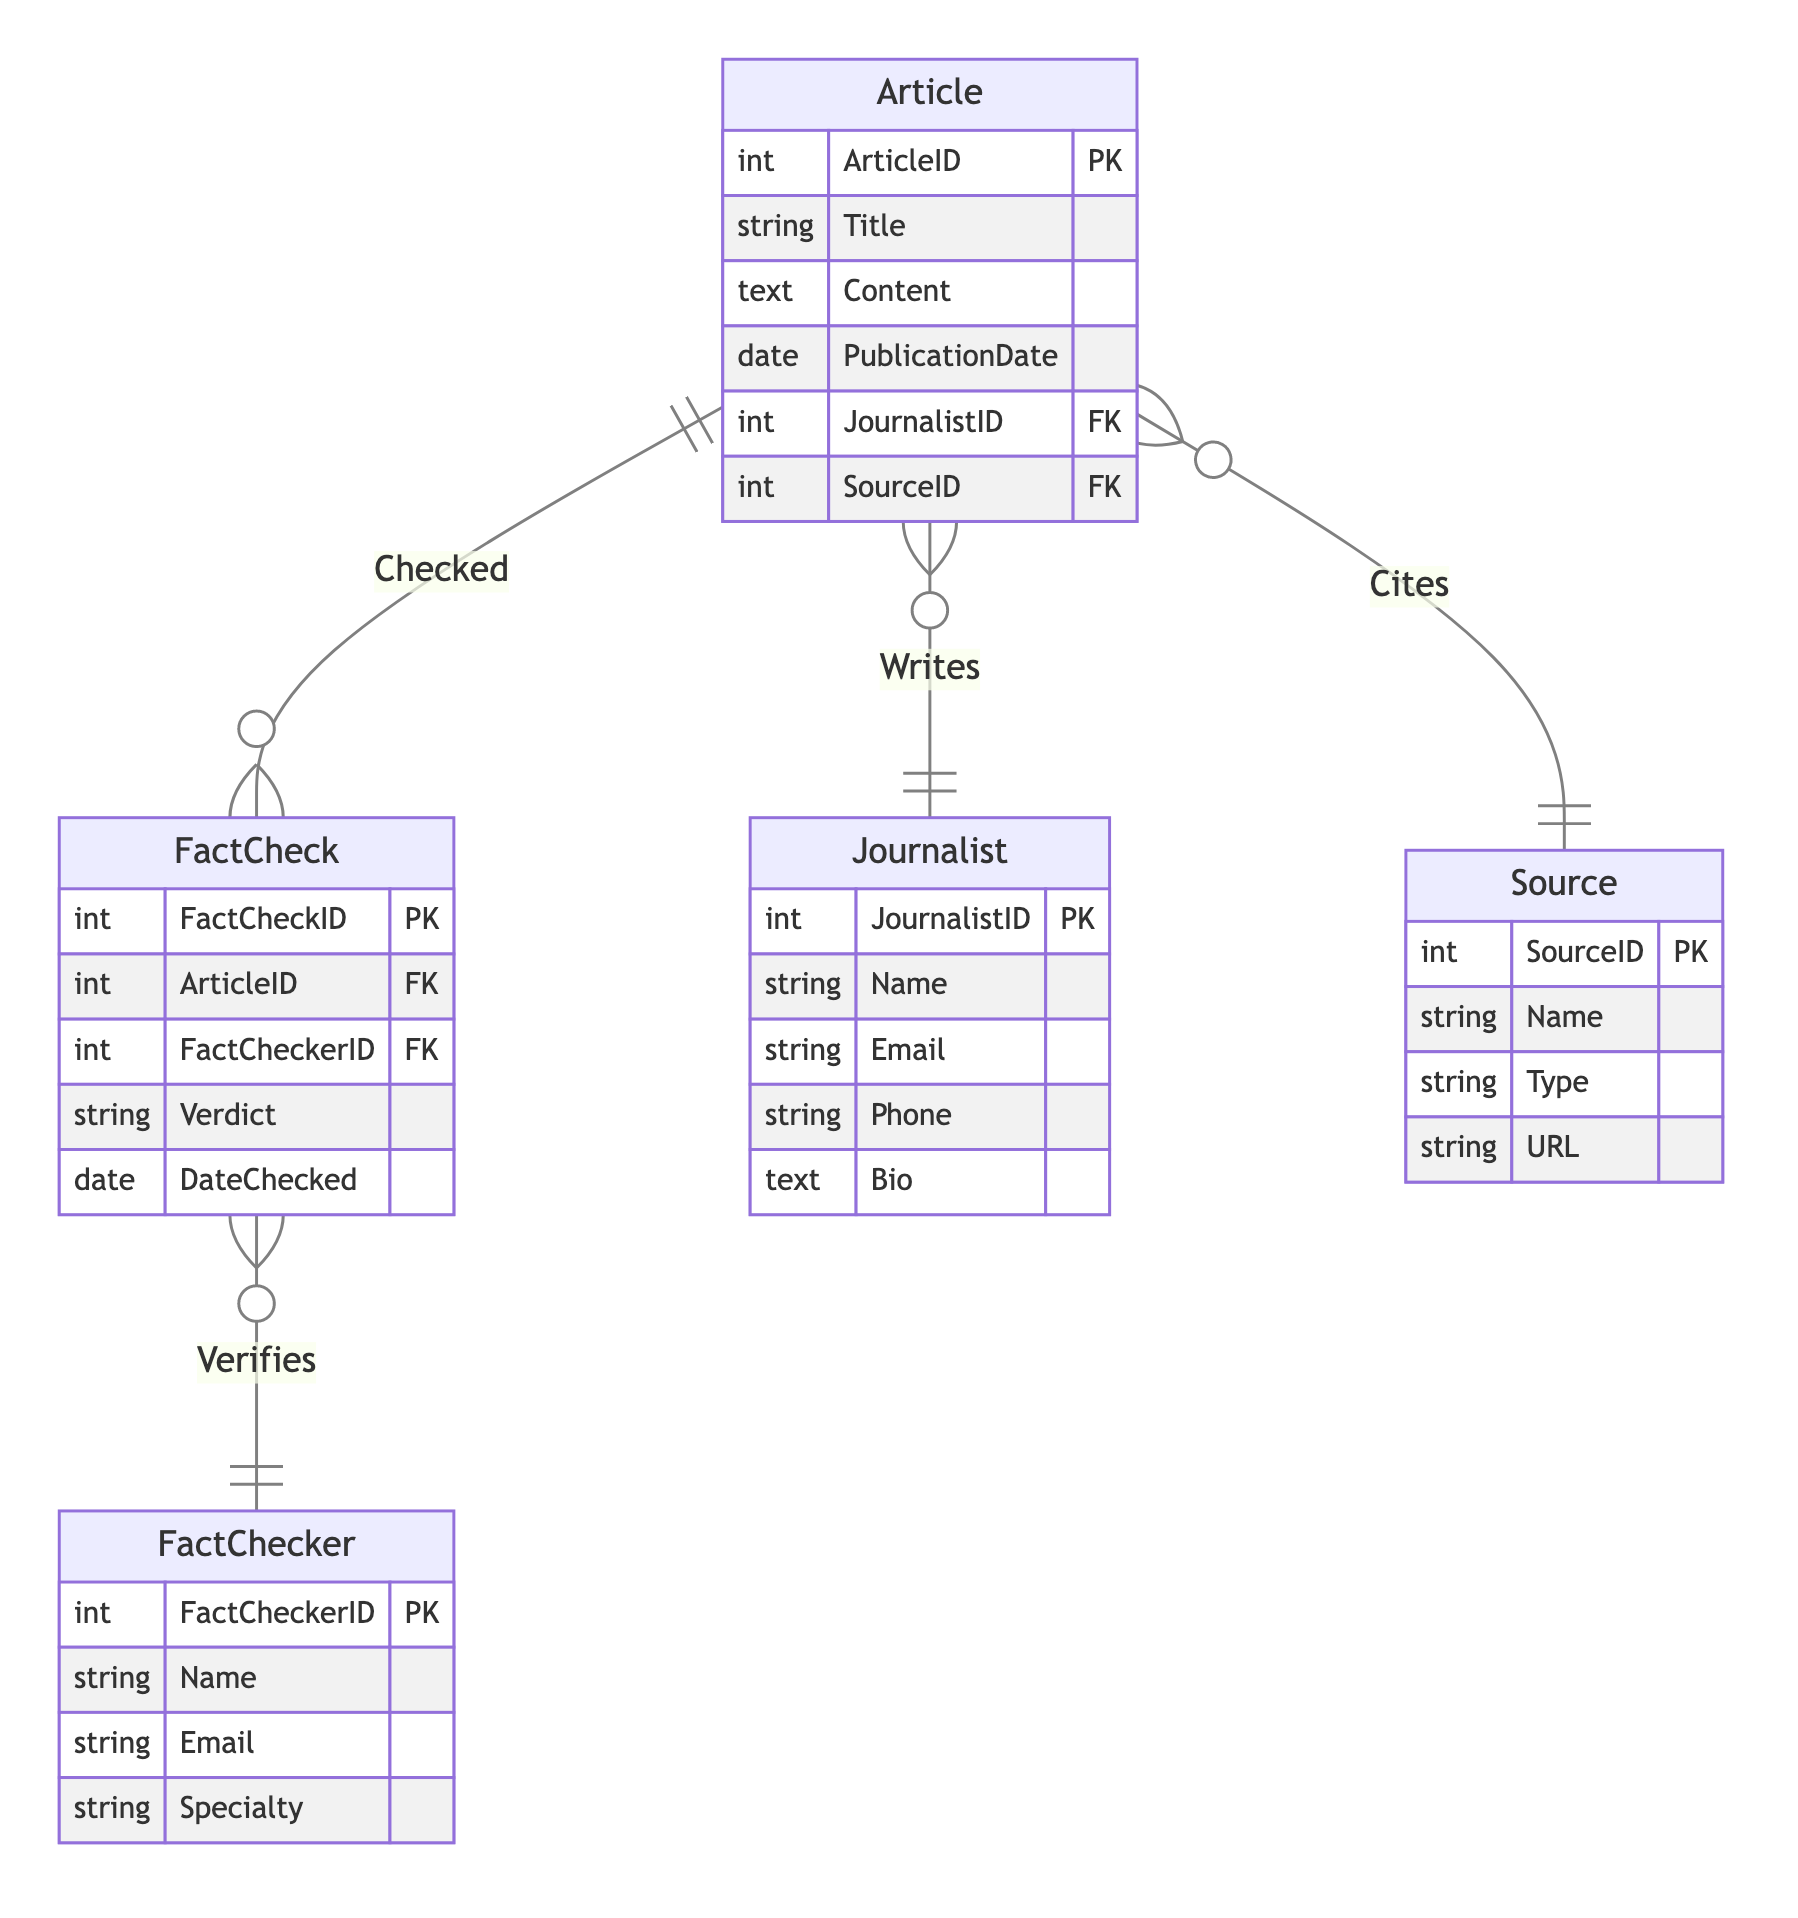What is the primary key of the Article entity? The primary key for the Article entity is specified in the diagram as ArticleID.
Answer: ArticleID How many entities are defined in the diagram? By counting the distinct entities listed in the diagram, there are five entities: Article, Journalist, Source, FactChecker, and FactCheck.
Answer: 5 What relationship exists between Journalist and Article? The diagram shows a relationship named "Writes" connecting the Journalist to the Article, indicating that journalists write articles.
Answer: Writes Which entity has the attribute 'Specialty'? The 'Specialty' attribute is found within the FactChecker entity as indicated in the diagram.
Answer: FactChecker What is the foreign key in the FactCheck entity? The diagram identifies the foreign keys in the FactCheck entity, which are ArticleID and FactCheckerID, linking it to Article and FactChecker respectively.
Answer: ArticleID, FactCheckerID Which entity is linked to Article via the 'Cites' relationship? The relationship 'Cites' connects the Article entity with the Source entity, indicating that articles cite sources.
Answer: Source What does the 'Verifies' relationship connect? In the diagram, the 'Verifies' relationship connects FactChecker and FactCheck, meaning fact-checkers verify the fact-checks.
Answer: FactChecker and FactCheck How many relationships involve the Article entity? The diagram showcases three relationships involving the Article entity: 'Writes', 'Cites', and 'Checked', thus there are three relationships associated with Article.
Answer: 3 What is the primary key for the FactCheck entity? The primary key for the FactCheck entity as shown in the diagram is FactCheckID.
Answer: FactCheckID 